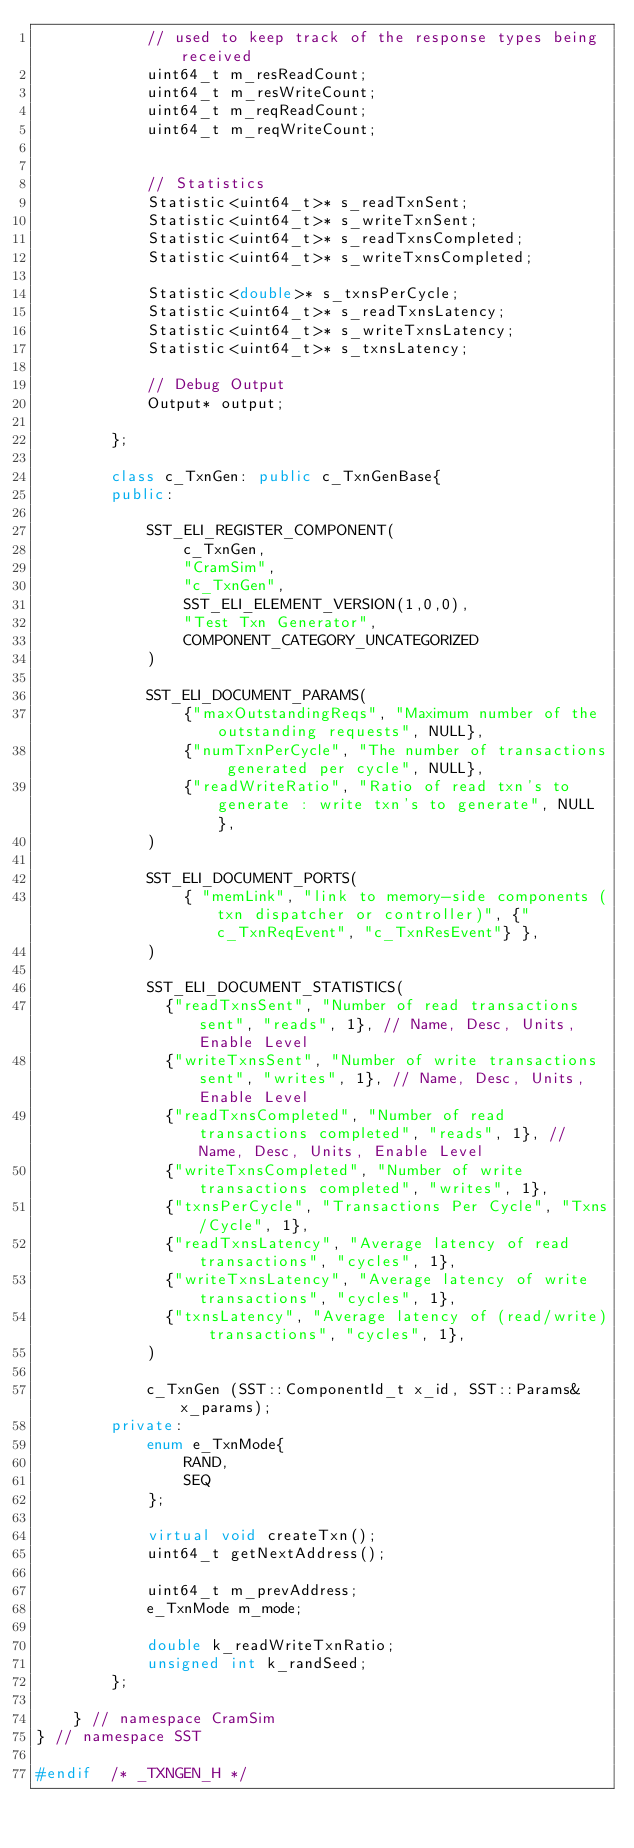<code> <loc_0><loc_0><loc_500><loc_500><_C++_>            // used to keep track of the response types being received
            uint64_t m_resReadCount;
            uint64_t m_resWriteCount;
            uint64_t m_reqReadCount;
            uint64_t m_reqWriteCount;


            // Statistics
            Statistic<uint64_t>* s_readTxnSent;
            Statistic<uint64_t>* s_writeTxnSent;
            Statistic<uint64_t>* s_readTxnsCompleted;
            Statistic<uint64_t>* s_writeTxnsCompleted;

            Statistic<double>* s_txnsPerCycle;
            Statistic<uint64_t>* s_readTxnsLatency;
            Statistic<uint64_t>* s_writeTxnsLatency;
            Statistic<uint64_t>* s_txnsLatency;

            // Debug Output
            Output* output;

        };

        class c_TxnGen: public c_TxnGenBase{
        public:

            SST_ELI_REGISTER_COMPONENT(
                c_TxnGen,
                "CramSim",
                "c_TxnGen",
                SST_ELI_ELEMENT_VERSION(1,0,0),
                "Test Txn Generator",
                COMPONENT_CATEGORY_UNCATEGORIZED
            )

            SST_ELI_DOCUMENT_PARAMS(
                {"maxOutstandingReqs", "Maximum number of the outstanding requests", NULL},
                {"numTxnPerCycle", "The number of transactions generated per cycle", NULL},
                {"readWriteRatio", "Ratio of read txn's to generate : write txn's to generate", NULL},
            )

            SST_ELI_DOCUMENT_PORTS(
                { "memLink", "link to memory-side components (txn dispatcher or controller)", {"c_TxnReqEvent", "c_TxnResEvent"} },
            )

            SST_ELI_DOCUMENT_STATISTICS(
              {"readTxnsSent", "Number of read transactions sent", "reads", 1}, // Name, Desc, Units, Enable Level
              {"writeTxnsSent", "Number of write transactions sent", "writes", 1}, // Name, Desc, Units, Enable Level
              {"readTxnsCompleted", "Number of read transactions completed", "reads", 1}, // Name, Desc, Units, Enable Level
              {"writeTxnsCompleted", "Number of write transactions completed", "writes", 1},
              {"txnsPerCycle", "Transactions Per Cycle", "Txns/Cycle", 1},
              {"readTxnsLatency", "Average latency of read transactions", "cycles", 1},
              {"writeTxnsLatency", "Average latency of write transactions", "cycles", 1},
              {"txnsLatency", "Average latency of (read/write) transactions", "cycles", 1},
            )

            c_TxnGen (SST::ComponentId_t x_id, SST::Params& x_params);
        private:
            enum e_TxnMode{
                RAND,
                SEQ
            };

            virtual void createTxn();
            uint64_t getNextAddress();

            uint64_t m_prevAddress;
            e_TxnMode m_mode;

            double k_readWriteTxnRatio;
            unsigned int k_randSeed;
        };

    } // namespace CramSim
} // namespace SST

#endif  /* _TXNGEN_H */
</code> 